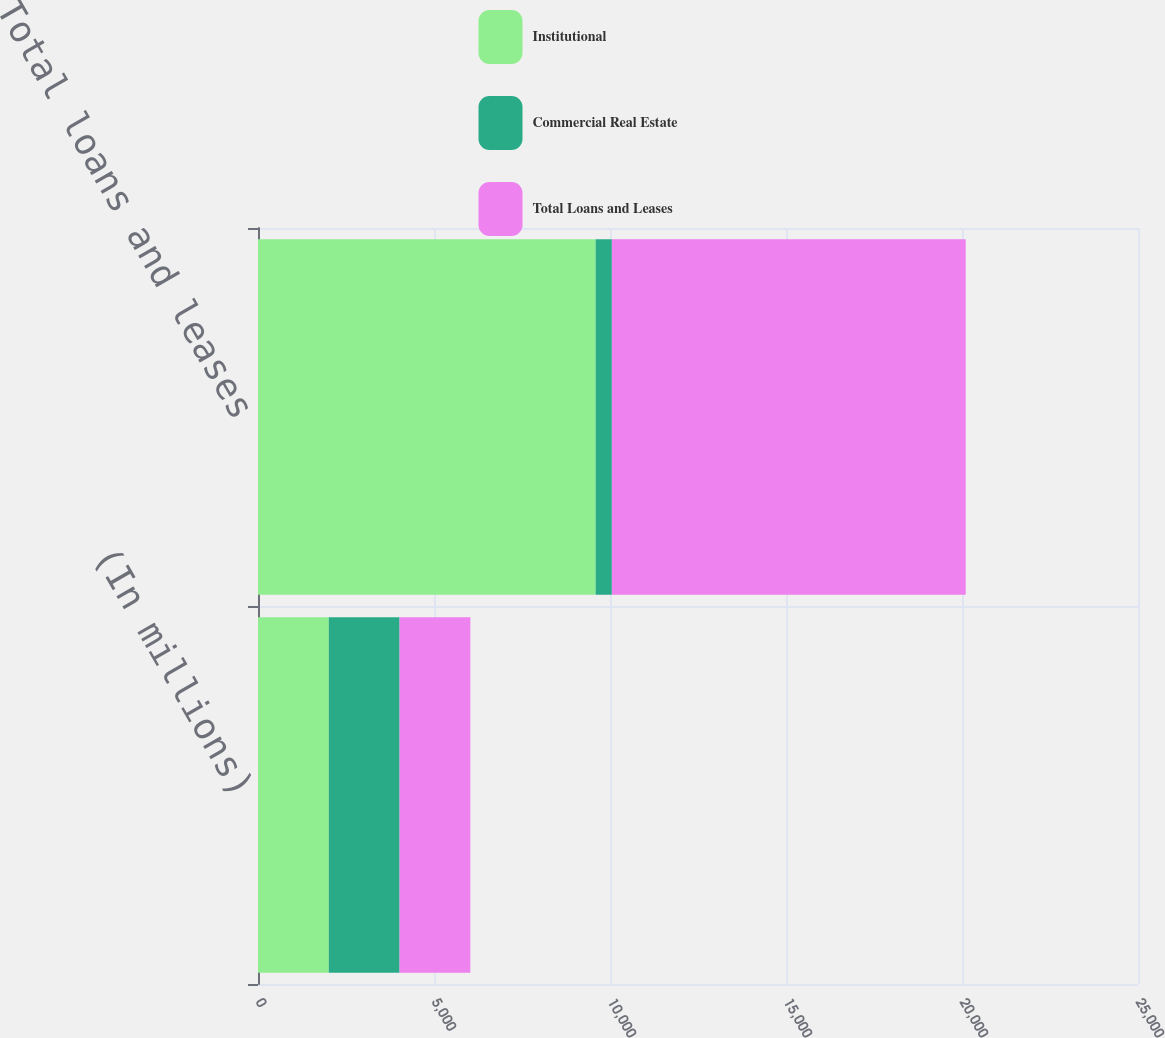Convert chart to OTSL. <chart><loc_0><loc_0><loc_500><loc_500><stacked_bar_chart><ecel><fcel>(In millions)<fcel>Total loans and leases<nl><fcel>Institutional<fcel>2011<fcel>9593<nl><fcel>Commercial Real Estate<fcel>2011<fcel>460<nl><fcel>Total Loans and Leases<fcel>2011<fcel>10053<nl></chart> 